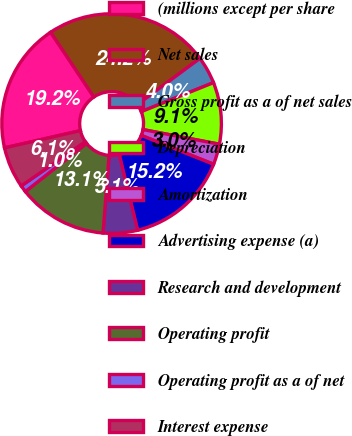Convert chart. <chart><loc_0><loc_0><loc_500><loc_500><pie_chart><fcel>(millions except per share<fcel>Net sales<fcel>Gross profit as a of net sales<fcel>Depreciation<fcel>Amortization<fcel>Advertising expense (a)<fcel>Research and development<fcel>Operating profit<fcel>Operating profit as a of net<fcel>Interest expense<nl><fcel>19.19%<fcel>24.24%<fcel>4.04%<fcel>9.09%<fcel>3.03%<fcel>15.15%<fcel>5.05%<fcel>13.13%<fcel>1.01%<fcel>6.06%<nl></chart> 